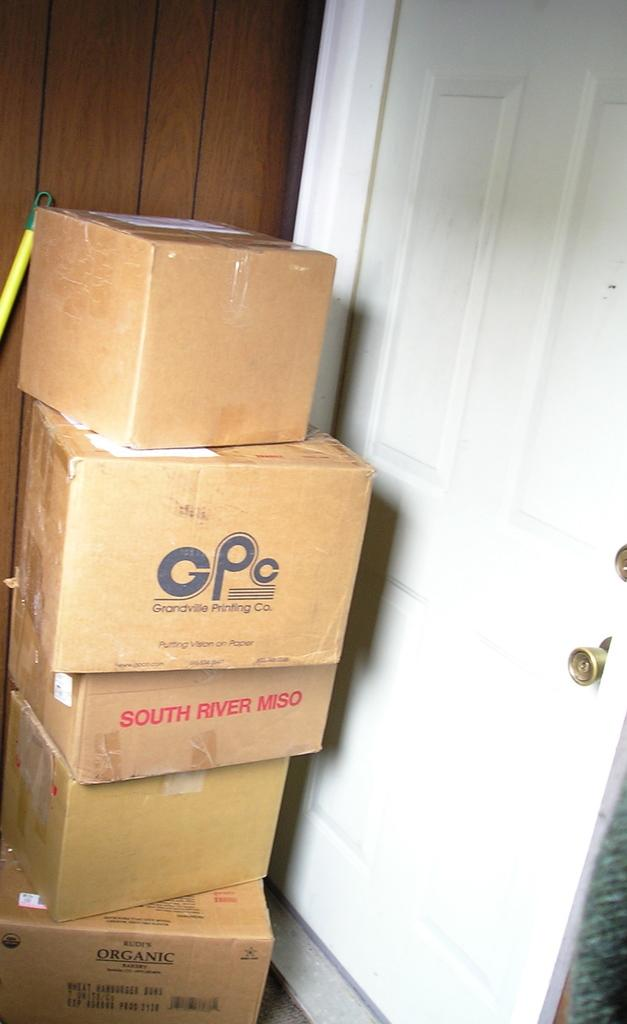<image>
Write a terse but informative summary of the picture. The collection of boxes are stacked on top of each other with the second box with the leters GPC on it. 